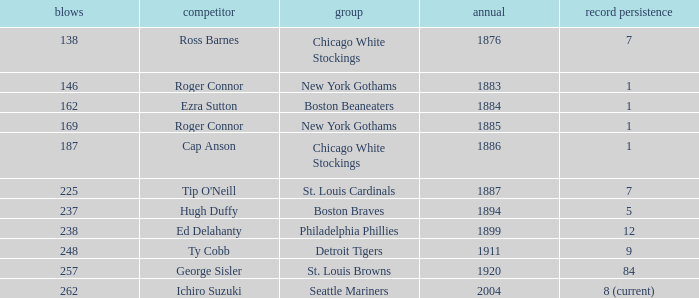Name the player with 238 hits and years after 1885 Ed Delahanty. 